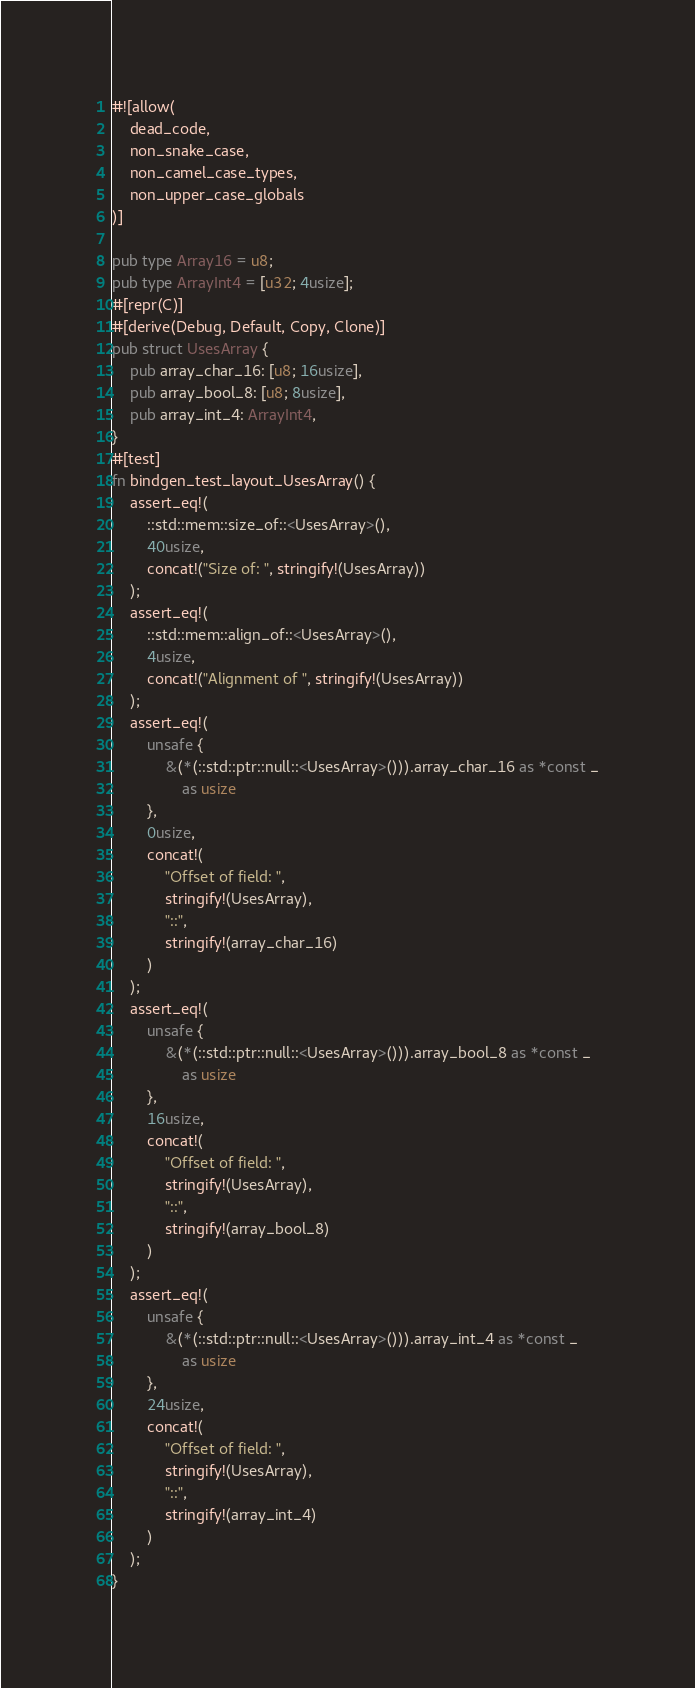<code> <loc_0><loc_0><loc_500><loc_500><_Rust_>#![allow(
    dead_code,
    non_snake_case,
    non_camel_case_types,
    non_upper_case_globals
)]

pub type Array16 = u8;
pub type ArrayInt4 = [u32; 4usize];
#[repr(C)]
#[derive(Debug, Default, Copy, Clone)]
pub struct UsesArray {
    pub array_char_16: [u8; 16usize],
    pub array_bool_8: [u8; 8usize],
    pub array_int_4: ArrayInt4,
}
#[test]
fn bindgen_test_layout_UsesArray() {
    assert_eq!(
        ::std::mem::size_of::<UsesArray>(),
        40usize,
        concat!("Size of: ", stringify!(UsesArray))
    );
    assert_eq!(
        ::std::mem::align_of::<UsesArray>(),
        4usize,
        concat!("Alignment of ", stringify!(UsesArray))
    );
    assert_eq!(
        unsafe {
            &(*(::std::ptr::null::<UsesArray>())).array_char_16 as *const _
                as usize
        },
        0usize,
        concat!(
            "Offset of field: ",
            stringify!(UsesArray),
            "::",
            stringify!(array_char_16)
        )
    );
    assert_eq!(
        unsafe {
            &(*(::std::ptr::null::<UsesArray>())).array_bool_8 as *const _
                as usize
        },
        16usize,
        concat!(
            "Offset of field: ",
            stringify!(UsesArray),
            "::",
            stringify!(array_bool_8)
        )
    );
    assert_eq!(
        unsafe {
            &(*(::std::ptr::null::<UsesArray>())).array_int_4 as *const _
                as usize
        },
        24usize,
        concat!(
            "Offset of field: ",
            stringify!(UsesArray),
            "::",
            stringify!(array_int_4)
        )
    );
}
</code> 